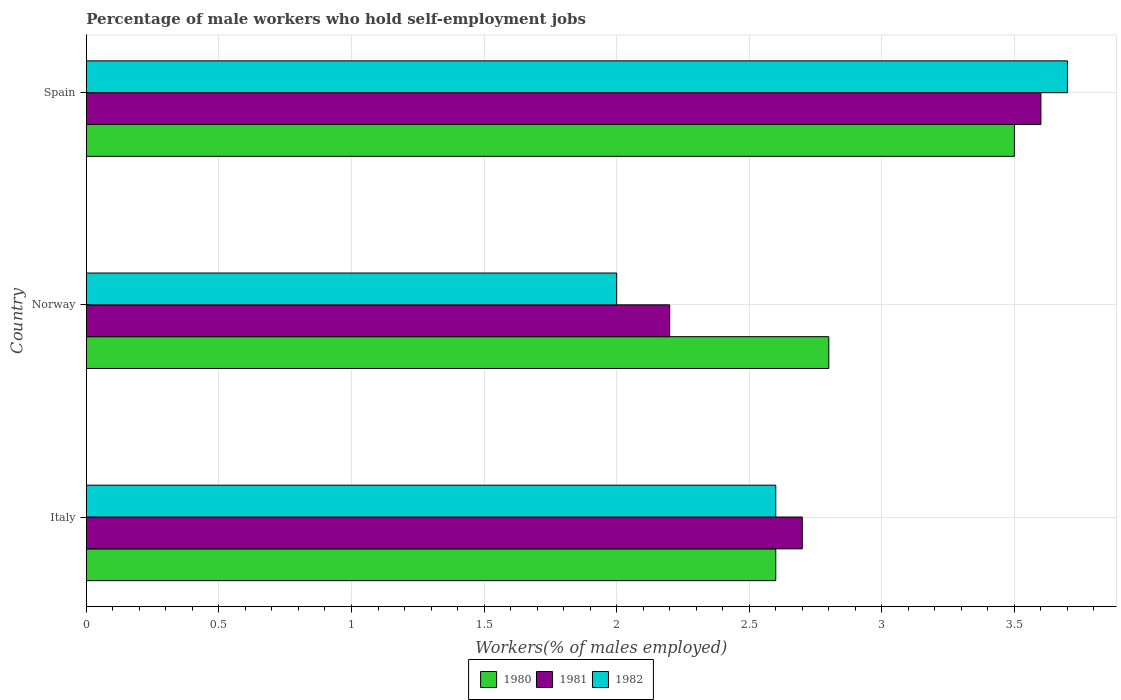How many different coloured bars are there?
Provide a succinct answer. 3. How many groups of bars are there?
Keep it short and to the point. 3. Are the number of bars on each tick of the Y-axis equal?
Offer a very short reply. Yes. How many bars are there on the 2nd tick from the bottom?
Your answer should be very brief. 3. What is the label of the 1st group of bars from the top?
Your response must be concise. Spain. What is the percentage of self-employed male workers in 1982 in Norway?
Provide a short and direct response. 2. Across all countries, what is the minimum percentage of self-employed male workers in 1982?
Make the answer very short. 2. In which country was the percentage of self-employed male workers in 1981 maximum?
Provide a succinct answer. Spain. In which country was the percentage of self-employed male workers in 1980 minimum?
Provide a succinct answer. Italy. What is the total percentage of self-employed male workers in 1981 in the graph?
Offer a terse response. 8.5. What is the difference between the percentage of self-employed male workers in 1980 in Italy and that in Spain?
Give a very brief answer. -0.9. What is the difference between the percentage of self-employed male workers in 1980 in Italy and the percentage of self-employed male workers in 1982 in Spain?
Ensure brevity in your answer.  -1.1. What is the average percentage of self-employed male workers in 1982 per country?
Provide a short and direct response. 2.77. What is the difference between the percentage of self-employed male workers in 1981 and percentage of self-employed male workers in 1982 in Spain?
Your answer should be very brief. -0.1. What is the ratio of the percentage of self-employed male workers in 1982 in Italy to that in Norway?
Provide a succinct answer. 1.3. Is the difference between the percentage of self-employed male workers in 1981 in Norway and Spain greater than the difference between the percentage of self-employed male workers in 1982 in Norway and Spain?
Keep it short and to the point. Yes. What is the difference between the highest and the second highest percentage of self-employed male workers in 1981?
Give a very brief answer. 0.9. What is the difference between the highest and the lowest percentage of self-employed male workers in 1980?
Ensure brevity in your answer.  0.9. In how many countries, is the percentage of self-employed male workers in 1981 greater than the average percentage of self-employed male workers in 1981 taken over all countries?
Keep it short and to the point. 1. What does the 1st bar from the top in Norway represents?
Provide a succinct answer. 1982. What does the 1st bar from the bottom in Italy represents?
Your answer should be very brief. 1980. Is it the case that in every country, the sum of the percentage of self-employed male workers in 1981 and percentage of self-employed male workers in 1982 is greater than the percentage of self-employed male workers in 1980?
Give a very brief answer. Yes. How many bars are there?
Your answer should be compact. 9. What is the difference between two consecutive major ticks on the X-axis?
Your answer should be compact. 0.5. Does the graph contain any zero values?
Ensure brevity in your answer.  No. How many legend labels are there?
Your answer should be compact. 3. How are the legend labels stacked?
Keep it short and to the point. Horizontal. What is the title of the graph?
Provide a succinct answer. Percentage of male workers who hold self-employment jobs. Does "1972" appear as one of the legend labels in the graph?
Your response must be concise. No. What is the label or title of the X-axis?
Your response must be concise. Workers(% of males employed). What is the Workers(% of males employed) in 1980 in Italy?
Provide a succinct answer. 2.6. What is the Workers(% of males employed) of 1981 in Italy?
Your answer should be compact. 2.7. What is the Workers(% of males employed) of 1982 in Italy?
Offer a very short reply. 2.6. What is the Workers(% of males employed) in 1980 in Norway?
Give a very brief answer. 2.8. What is the Workers(% of males employed) in 1981 in Norway?
Give a very brief answer. 2.2. What is the Workers(% of males employed) in 1982 in Norway?
Ensure brevity in your answer.  2. What is the Workers(% of males employed) in 1980 in Spain?
Keep it short and to the point. 3.5. What is the Workers(% of males employed) in 1981 in Spain?
Provide a short and direct response. 3.6. What is the Workers(% of males employed) in 1982 in Spain?
Offer a terse response. 3.7. Across all countries, what is the maximum Workers(% of males employed) in 1981?
Your response must be concise. 3.6. Across all countries, what is the maximum Workers(% of males employed) in 1982?
Make the answer very short. 3.7. Across all countries, what is the minimum Workers(% of males employed) in 1980?
Your answer should be very brief. 2.6. Across all countries, what is the minimum Workers(% of males employed) of 1981?
Your response must be concise. 2.2. What is the total Workers(% of males employed) of 1980 in the graph?
Give a very brief answer. 8.9. What is the total Workers(% of males employed) of 1981 in the graph?
Provide a succinct answer. 8.5. What is the difference between the Workers(% of males employed) in 1980 in Italy and that in Norway?
Give a very brief answer. -0.2. What is the difference between the Workers(% of males employed) of 1982 in Italy and that in Norway?
Your answer should be compact. 0.6. What is the difference between the Workers(% of males employed) in 1980 in Italy and that in Spain?
Give a very brief answer. -0.9. What is the difference between the Workers(% of males employed) in 1982 in Italy and that in Spain?
Provide a short and direct response. -1.1. What is the difference between the Workers(% of males employed) in 1980 in Norway and that in Spain?
Make the answer very short. -0.7. What is the difference between the Workers(% of males employed) of 1981 in Italy and the Workers(% of males employed) of 1982 in Norway?
Provide a short and direct response. 0.7. What is the difference between the Workers(% of males employed) in 1980 in Italy and the Workers(% of males employed) in 1982 in Spain?
Ensure brevity in your answer.  -1.1. What is the difference between the Workers(% of males employed) of 1980 in Norway and the Workers(% of males employed) of 1981 in Spain?
Keep it short and to the point. -0.8. What is the difference between the Workers(% of males employed) in 1981 in Norway and the Workers(% of males employed) in 1982 in Spain?
Your answer should be very brief. -1.5. What is the average Workers(% of males employed) of 1980 per country?
Provide a short and direct response. 2.97. What is the average Workers(% of males employed) in 1981 per country?
Your answer should be very brief. 2.83. What is the average Workers(% of males employed) of 1982 per country?
Provide a succinct answer. 2.77. What is the difference between the Workers(% of males employed) in 1980 and Workers(% of males employed) in 1982 in Italy?
Ensure brevity in your answer.  0. What is the difference between the Workers(% of males employed) in 1980 and Workers(% of males employed) in 1982 in Norway?
Your answer should be very brief. 0.8. What is the difference between the Workers(% of males employed) of 1981 and Workers(% of males employed) of 1982 in Spain?
Give a very brief answer. -0.1. What is the ratio of the Workers(% of males employed) in 1981 in Italy to that in Norway?
Offer a terse response. 1.23. What is the ratio of the Workers(% of males employed) in 1980 in Italy to that in Spain?
Offer a very short reply. 0.74. What is the ratio of the Workers(% of males employed) of 1981 in Italy to that in Spain?
Your answer should be very brief. 0.75. What is the ratio of the Workers(% of males employed) of 1982 in Italy to that in Spain?
Your response must be concise. 0.7. What is the ratio of the Workers(% of males employed) in 1981 in Norway to that in Spain?
Offer a very short reply. 0.61. What is the ratio of the Workers(% of males employed) of 1982 in Norway to that in Spain?
Make the answer very short. 0.54. What is the difference between the highest and the second highest Workers(% of males employed) in 1980?
Offer a very short reply. 0.7. What is the difference between the highest and the second highest Workers(% of males employed) in 1981?
Ensure brevity in your answer.  0.9. What is the difference between the highest and the lowest Workers(% of males employed) of 1981?
Offer a terse response. 1.4. What is the difference between the highest and the lowest Workers(% of males employed) of 1982?
Your answer should be compact. 1.7. 